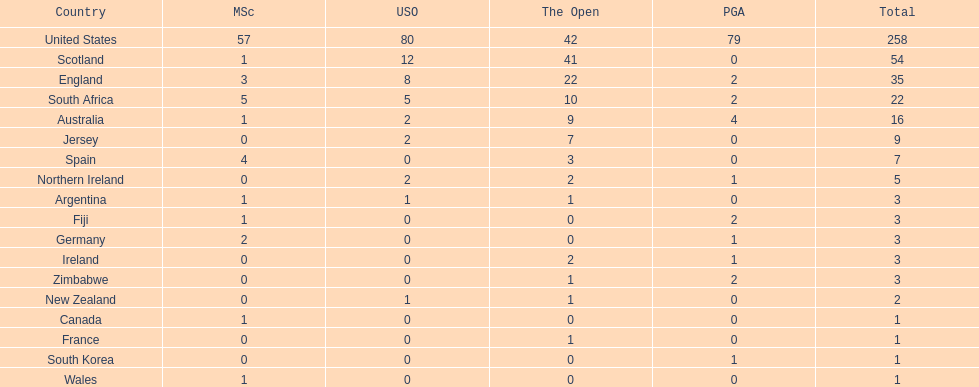Could you help me parse every detail presented in this table? {'header': ['Country', 'MSc', 'USO', 'The Open', 'PGA', 'Total'], 'rows': [['United States', '57', '80', '42', '79', '258'], ['Scotland', '1', '12', '41', '0', '54'], ['England', '3', '8', '22', '2', '35'], ['South Africa', '5', '5', '10', '2', '22'], ['Australia', '1', '2', '9', '4', '16'], ['Jersey', '0', '2', '7', '0', '9'], ['Spain', '4', '0', '3', '0', '7'], ['Northern Ireland', '0', '2', '2', '1', '5'], ['Argentina', '1', '1', '1', '0', '3'], ['Fiji', '1', '0', '0', '2', '3'], ['Germany', '2', '0', '0', '1', '3'], ['Ireland', '0', '0', '2', '1', '3'], ['Zimbabwe', '0', '0', '1', '2', '3'], ['New Zealand', '0', '1', '1', '0', '2'], ['Canada', '1', '0', '0', '0', '1'], ['France', '0', '0', '1', '0', '1'], ['South Korea', '0', '0', '0', '1', '1'], ['Wales', '1', '0', '0', '0', '1']]} How many countries have produced the same number of championship golfers as canada? 3. 